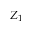Convert formula to latex. <formula><loc_0><loc_0><loc_500><loc_500>Z _ { 1 }</formula> 